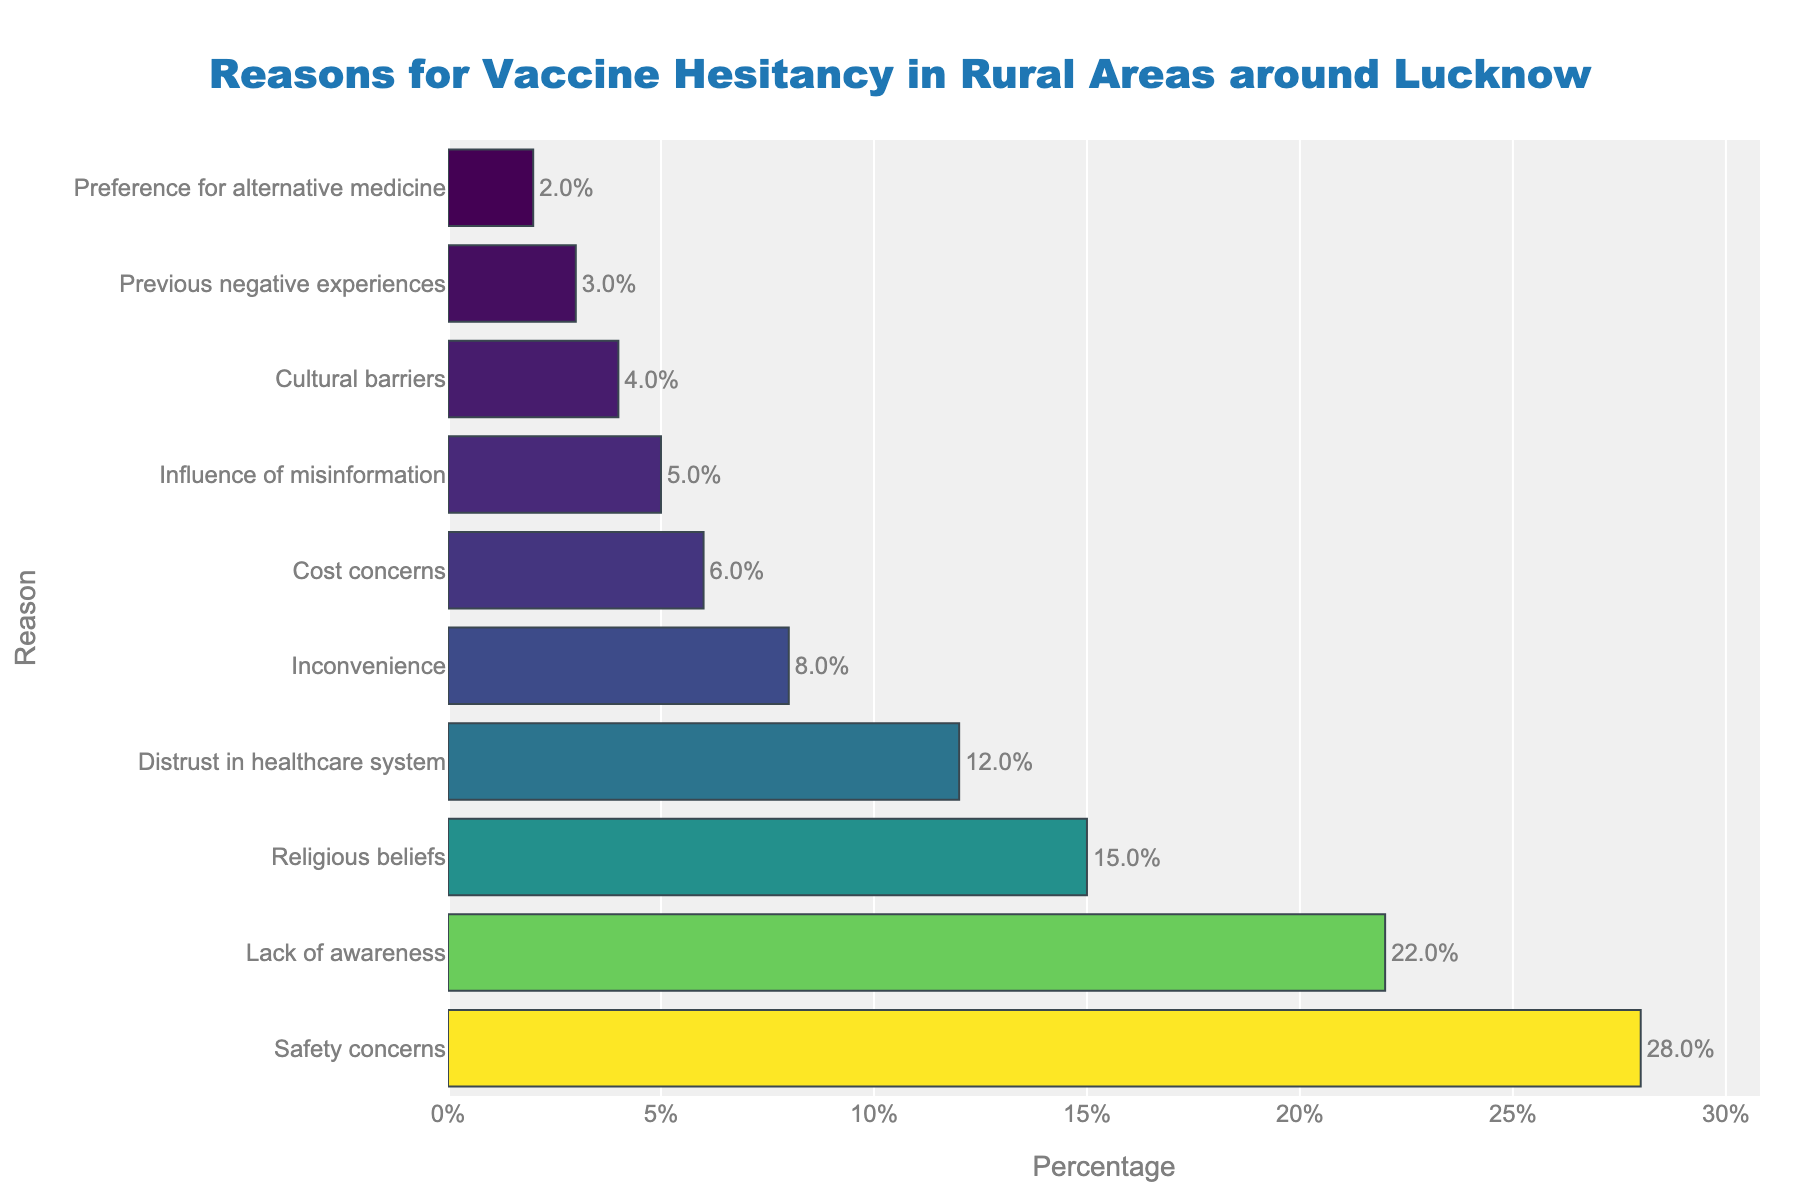Which reason for vaccine hesitancy is cited the most? Look at the bar with the greatest length. The longest bar represents 'Safety concerns' at 28%.
Answer: Safety concerns Which reason is cited the least for vaccine hesitancy? Identify the shortest bar in the chart. The shortest bar is 'Preference for alternative medicine' at 2%.
Answer: Preference for alternative medicine What is the total percentage of reasons related to concerns about the healthcare system (Distrust in healthcare system and Cost concerns)? Add the percentages for 'Distrust in healthcare system' (12%) and 'Cost concerns' (6%). 12% + 6% = 18%.
Answer: 18% How much higher is 'Safety concerns' compared to 'Lack of awareness'? Subtract the percentage of 'Lack of awareness' (22%) from 'Safety concerns' (28%). 28% - 22% = 6%.
Answer: 6% Compare 'Influence of misinformation' and 'Cultural barriers'. Which one has a higher percentage, and by how much? Determine the percentages for both: 'Influence of misinformation' is 5% and 'Cultural barriers' is 4%. 5% - 4% = 1%. 'Influence of misinformation' is higher by 1%.
Answer: Influence of misinformation by 1% What is the combined percentage of reasons related to personal beliefs (Religious beliefs and Cultural barriers)? Add the percentages for 'Religious beliefs' (15%) and 'Cultural barriers' (4%). 15% + 4% = 19%.
Answer: 19% Which reasons have a percentage of less than 10%? Identify all reasons with bars less than 10%. These are 'Inconvenience' (8%), 'Cost concerns' (6%), 'Influence of misinformation' (5%), 'Cultural barriers' (4%), 'Previous negative experiences' (3%), and 'Preference for alternative medicine' (2%).
Answer: Inconvenience, Cost concerns, Influence of misinformation, Cultural barriers, Previous negative experiences, Preference for alternative medicine What is the average percentage for 'Religious beliefs', 'Inconvenience', and 'Cost concerns'? Add the percentages and divide by the number of items. (15% + 8% + 6%) / 3 = 29% / 3 ≈ 9.67%.
Answer: 9.67% Which reason has a percentage about half of 'Safety concerns'? Determine which percentage is close to half of 'Safety concerns' (28%). Half of 28% is 14%. 'Religious beliefs' at 15% is closest to half.
Answer: Religious beliefs How many reasons have a percentage between 5% and 20%? Count the bars that fall within this range. The percentages that meet this criterion are 'Lack of awareness' (22%), 'Religious beliefs' (15%), 'Distrust in healthcare system' (12%), 'Inconvenience' (8%), 'Cost concerns' (6%), and 'Influence of misinformation' (5%). There are 6 reasons.
Answer: 6 